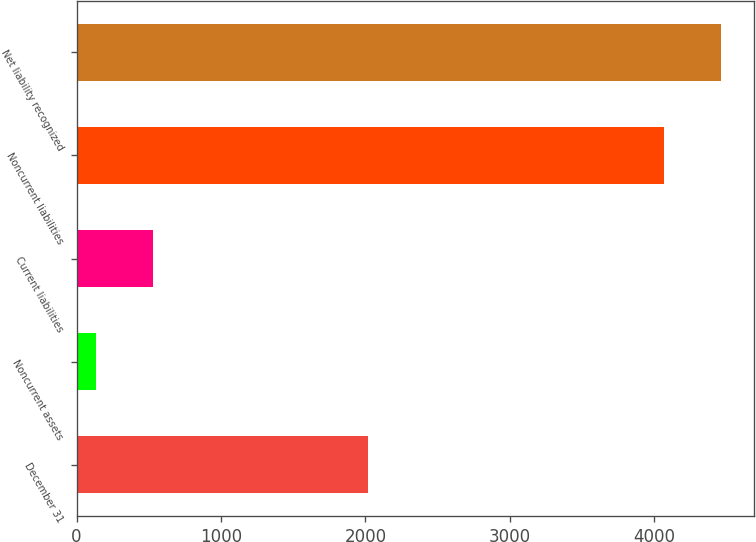<chart> <loc_0><loc_0><loc_500><loc_500><bar_chart><fcel>December 31<fcel>Noncurrent assets<fcel>Current liabilities<fcel>Noncurrent liabilities<fcel>Net liability recognized<nl><fcel>2017<fcel>133<fcel>527.9<fcel>4070<fcel>4464.9<nl></chart> 